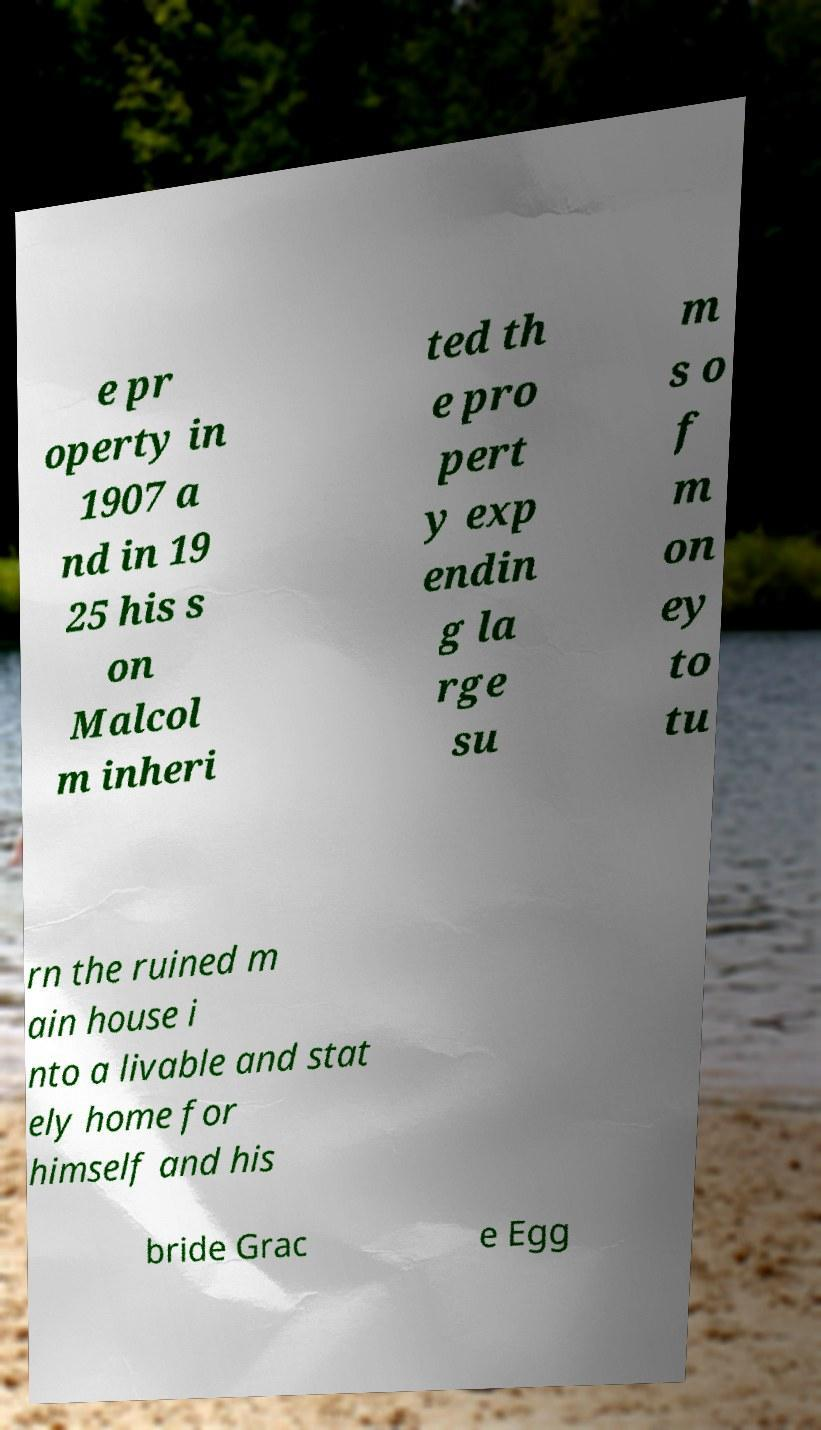Could you assist in decoding the text presented in this image and type it out clearly? e pr operty in 1907 a nd in 19 25 his s on Malcol m inheri ted th e pro pert y exp endin g la rge su m s o f m on ey to tu rn the ruined m ain house i nto a livable and stat ely home for himself and his bride Grac e Egg 